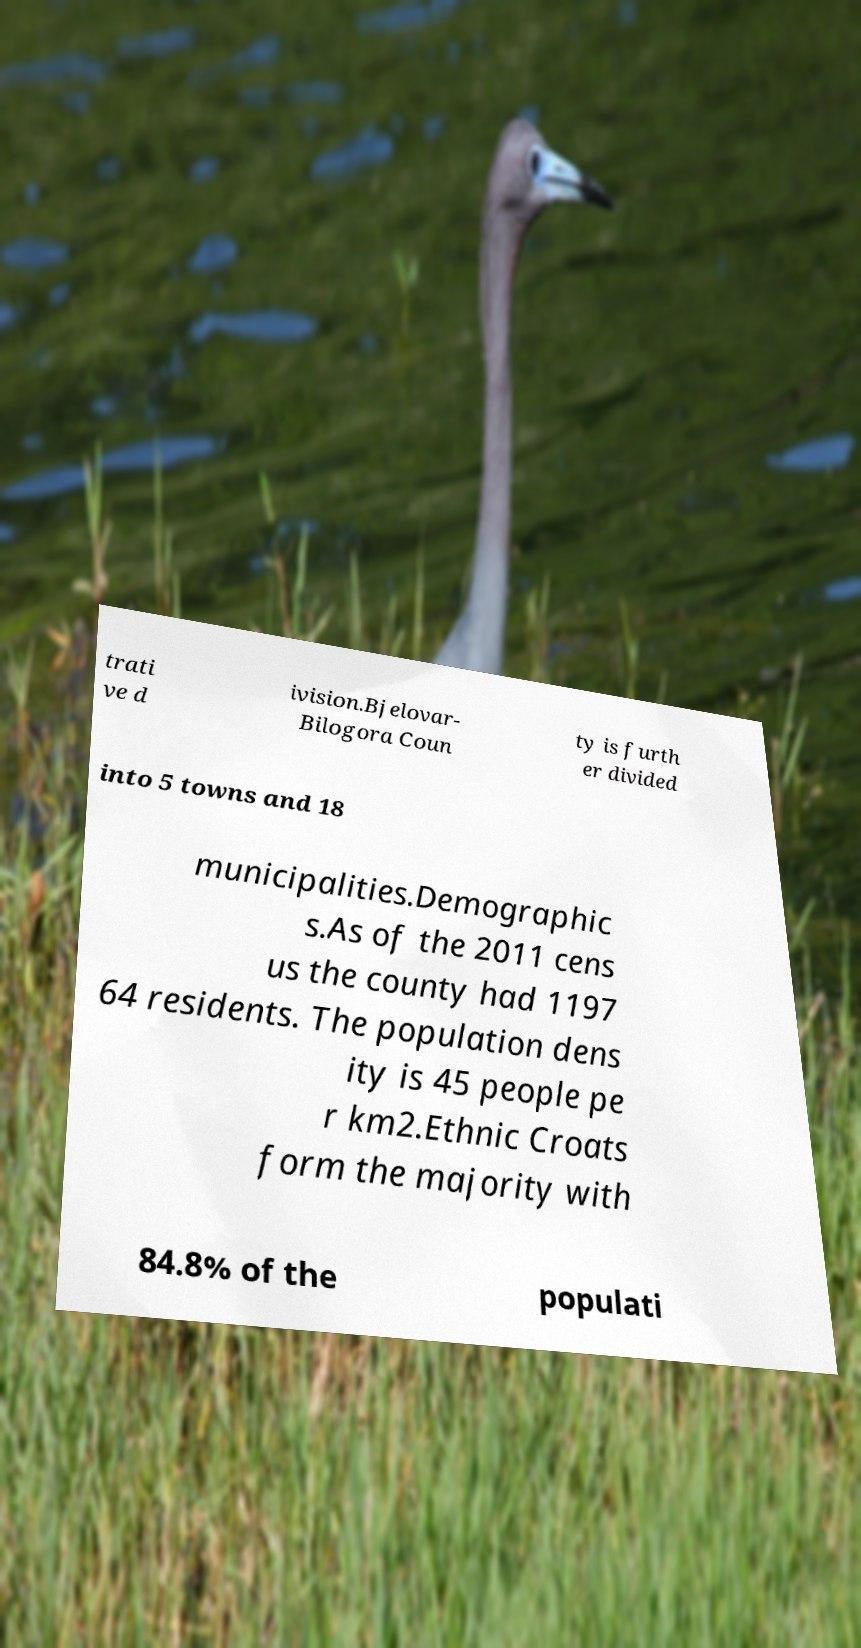Please identify and transcribe the text found in this image. trati ve d ivision.Bjelovar- Bilogora Coun ty is furth er divided into 5 towns and 18 municipalities.Demographic s.As of the 2011 cens us the county had 1197 64 residents. The population dens ity is 45 people pe r km2.Ethnic Croats form the majority with 84.8% of the populati 